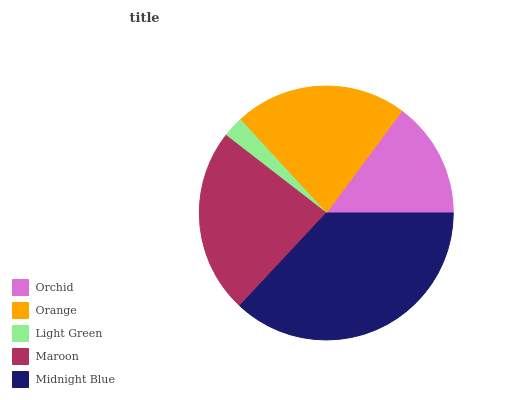Is Light Green the minimum?
Answer yes or no. Yes. Is Midnight Blue the maximum?
Answer yes or no. Yes. Is Orange the minimum?
Answer yes or no. No. Is Orange the maximum?
Answer yes or no. No. Is Orange greater than Orchid?
Answer yes or no. Yes. Is Orchid less than Orange?
Answer yes or no. Yes. Is Orchid greater than Orange?
Answer yes or no. No. Is Orange less than Orchid?
Answer yes or no. No. Is Orange the high median?
Answer yes or no. Yes. Is Orange the low median?
Answer yes or no. Yes. Is Midnight Blue the high median?
Answer yes or no. No. Is Orchid the low median?
Answer yes or no. No. 